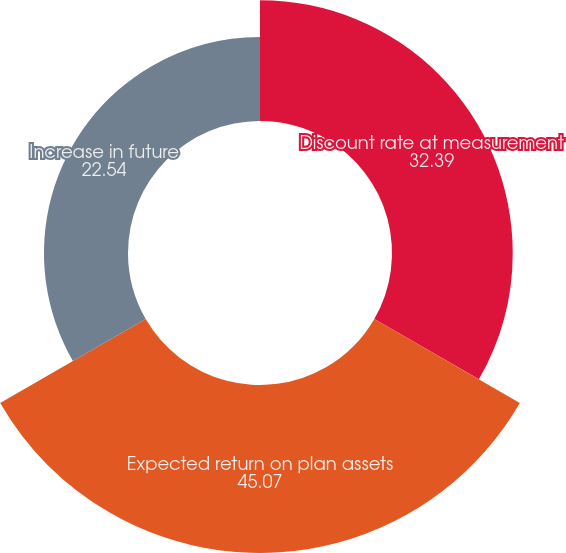Convert chart. <chart><loc_0><loc_0><loc_500><loc_500><pie_chart><fcel>Discount rate at measurement<fcel>Expected return on plan assets<fcel>Increase in future<nl><fcel>32.39%<fcel>45.07%<fcel>22.54%<nl></chart> 